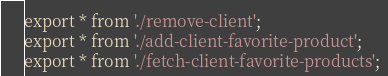Convert code to text. <code><loc_0><loc_0><loc_500><loc_500><_TypeScript_>export * from './remove-client';
export * from './add-client-favorite-product';
export * from './fetch-client-favorite-products';
</code> 